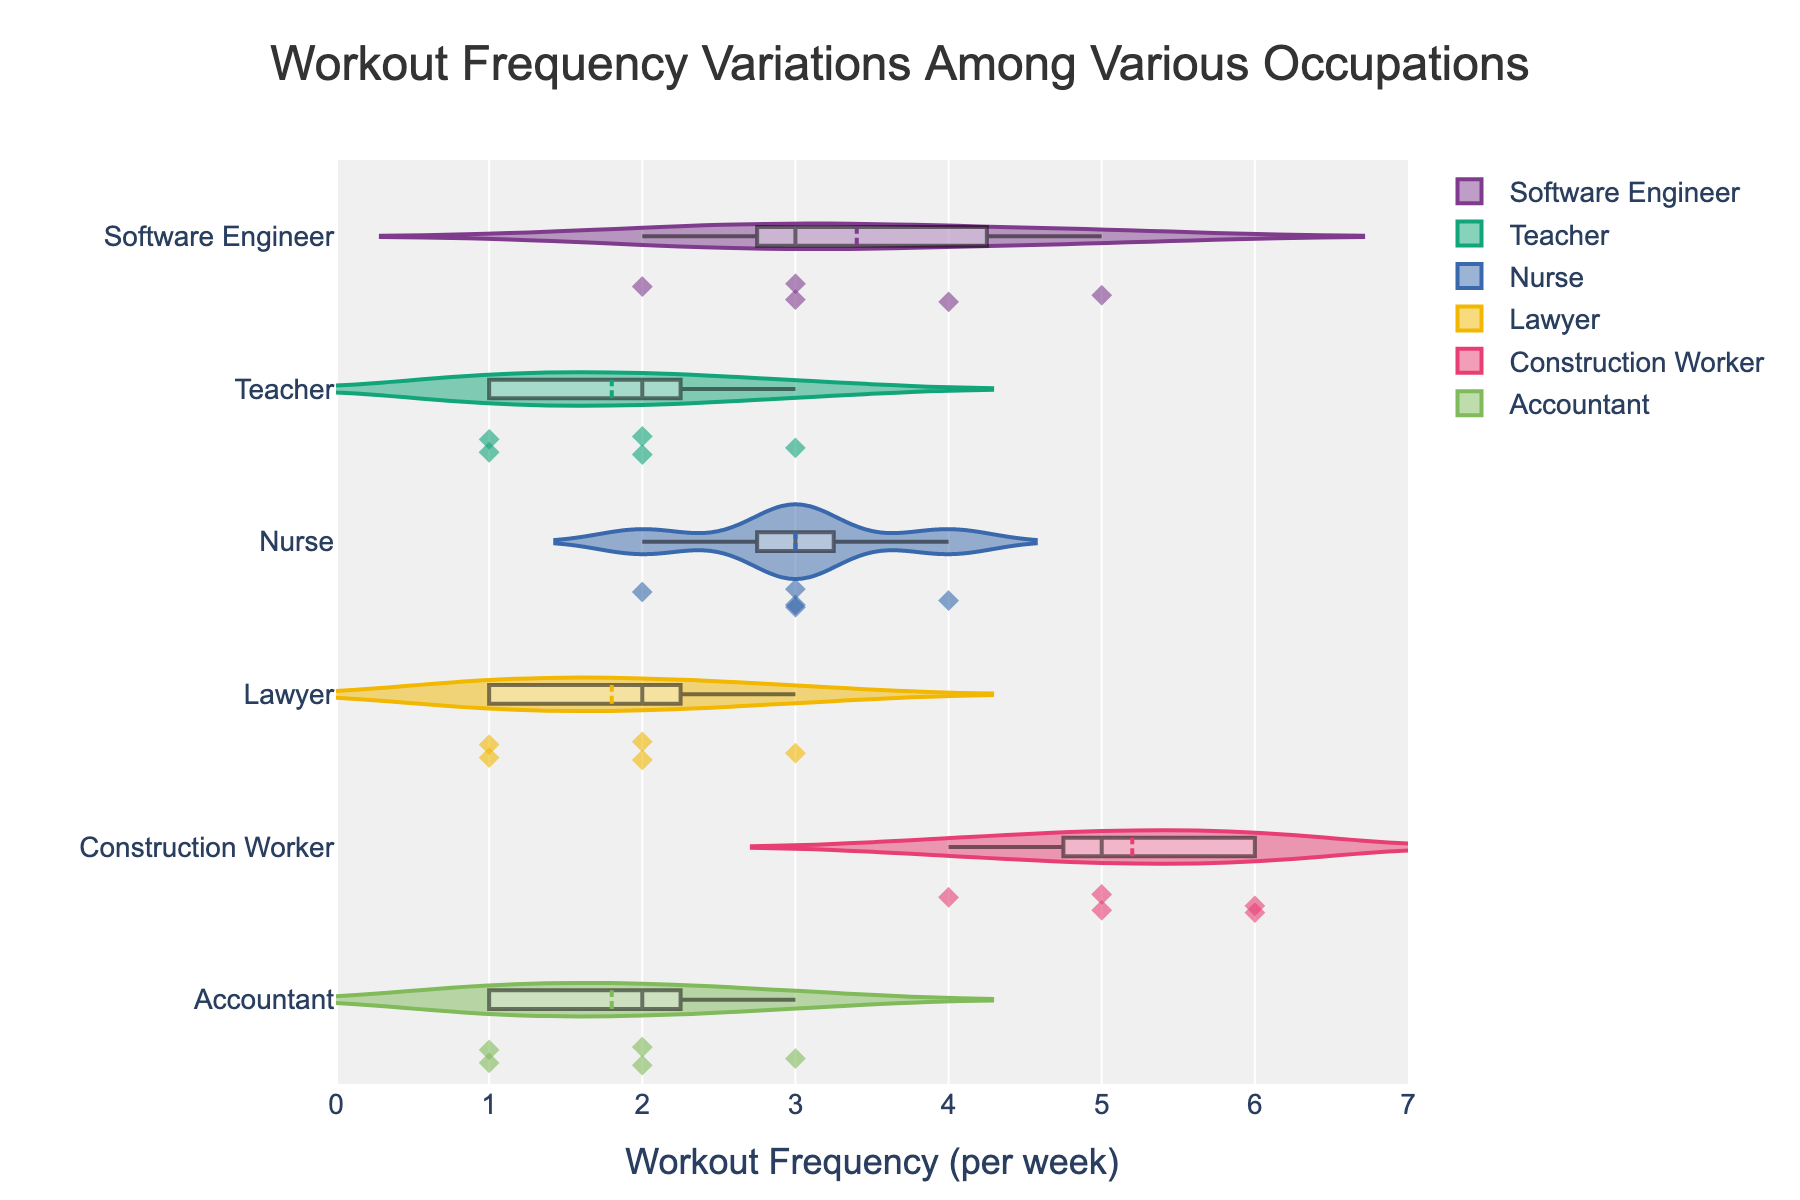What's the title of the figure? The title is displayed prominently at the top of the chart and reads "Workout Frequency Variations Among Various Occupations".
Answer: Workout Frequency Variations Among Various Occupations What is the range of workout frequency displayed on the x-axis? The x-axis visually represents the workout frequency per week, ranging from 0 to 7.
Answer: 0 to 7 Which occupation appears to have the highest median workout frequency? By observing the locations of the median lines on the violin plots, Construction Workers have their median line closest to the higher end of the x-axis.
Answer: Construction Workers What is the most common workout frequency for Nurses? From the plot, the thickest section of the violin plot for Nurses occurs around 3 workouts per week, indicating this is the most common value.
Answer: 3 Are there any occupations with outliers? If so, which ones? The plot shows discrete points outside the main body of some violin plots, indicating outliers. In this case, Teachers and Lawyers have outliers.
Answer: Teachers and Lawyers How does the workout frequency distribution for Teachers compare to Software Engineers? Teachers appear to work out less frequently overall compared to Software Engineers, as their distribution is more concentrated towards the lower end of the x-axis (1-2 times per week), while Software Engineers have a more spread out distribution towards higher frequencies.
Answer: Teachers generally work out less than Software Engineers Which occupation shows the widest range of workout frequencies? The spread of the violin plots indicates the range, and Construction Workers have the widest range with workout frequencies spanning from 4 to 6 times per week.
Answer: Construction Workers Between Accountants and Lawyers, who works out more frequently on average? The center of the distribution and the location of the median line indicate average frequency. Accountants have a slightly higher concentration toward 2-3 times per week, while Lawyers are more centered around 1-2 times per week.
Answer: Accountants Do any occupations have a similar workout frequency distribution? By examining the shapes and spread of the violin plots, Nurses and Software Engineers have somewhat similar workout frequency distributions, both showing concentration around 3 times per week but with spread towards higher frequencies.
Answer: Nurses and Software Engineers What is unique about the workout frequency distribution for Construction Workers compared to other occupations? The Construction Workers’ distribution is unique because it shows a high concentration around high workout frequencies (5-6 times per week), unlike other occupations which are centered at lower frequencies.
Answer: High concentration around 5-6 times per week 